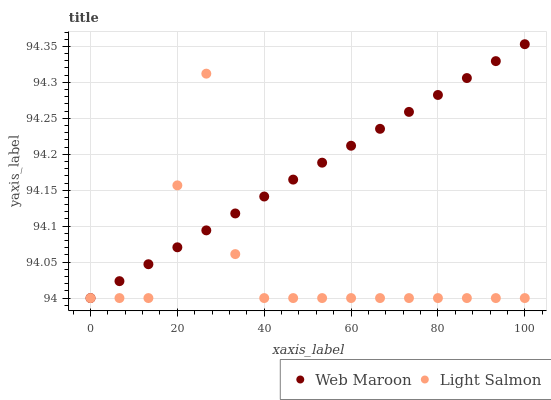Does Light Salmon have the minimum area under the curve?
Answer yes or no. Yes. Does Web Maroon have the maximum area under the curve?
Answer yes or no. Yes. Does Web Maroon have the minimum area under the curve?
Answer yes or no. No. Is Web Maroon the smoothest?
Answer yes or no. Yes. Is Light Salmon the roughest?
Answer yes or no. Yes. Is Web Maroon the roughest?
Answer yes or no. No. Does Light Salmon have the lowest value?
Answer yes or no. Yes. Does Web Maroon have the highest value?
Answer yes or no. Yes. Does Light Salmon intersect Web Maroon?
Answer yes or no. Yes. Is Light Salmon less than Web Maroon?
Answer yes or no. No. Is Light Salmon greater than Web Maroon?
Answer yes or no. No. 